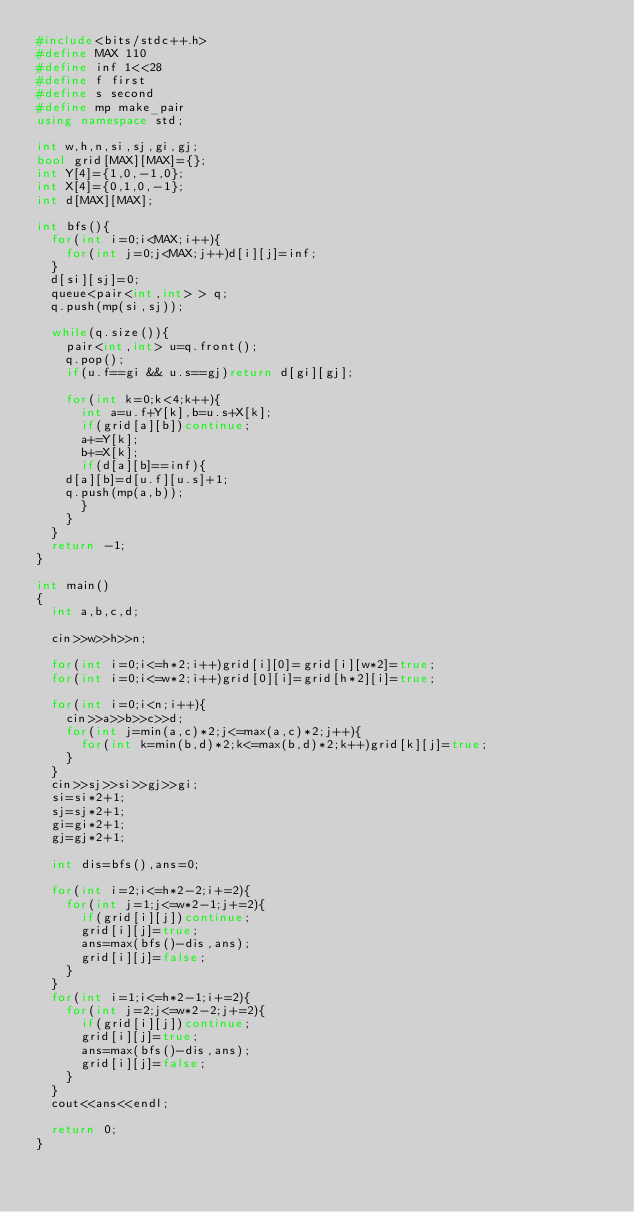<code> <loc_0><loc_0><loc_500><loc_500><_C++_>#include<bits/stdc++.h>
#define MAX 110
#define inf 1<<28
#define f first
#define s second
#define mp make_pair
using namespace std;

int w,h,n,si,sj,gi,gj;
bool grid[MAX][MAX]={};
int Y[4]={1,0,-1,0};
int X[4]={0,1,0,-1};
int d[MAX][MAX];

int bfs(){
  for(int i=0;i<MAX;i++){
    for(int j=0;j<MAX;j++)d[i][j]=inf;
  }
  d[si][sj]=0;
  queue<pair<int,int> > q;
  q.push(mp(si,sj));

  while(q.size()){
    pair<int,int> u=q.front();
    q.pop();
    if(u.f==gi && u.s==gj)return d[gi][gj];

    for(int k=0;k<4;k++){
      int a=u.f+Y[k],b=u.s+X[k];
      if(grid[a][b])continue;
      a+=Y[k];
      b+=X[k];
      if(d[a][b]==inf){
	d[a][b]=d[u.f][u.s]+1;
	q.push(mp(a,b));
      }
    }
  }
  return -1;
}

int main()
{
  int a,b,c,d;
 
  cin>>w>>h>>n;

  for(int i=0;i<=h*2;i++)grid[i][0]=grid[i][w*2]=true;
  for(int i=0;i<=w*2;i++)grid[0][i]=grid[h*2][i]=true;

  for(int i=0;i<n;i++){
    cin>>a>>b>>c>>d;
    for(int j=min(a,c)*2;j<=max(a,c)*2;j++){
      for(int k=min(b,d)*2;k<=max(b,d)*2;k++)grid[k][j]=true;
    }
  }
  cin>>sj>>si>>gj>>gi;
  si=si*2+1;
  sj=sj*2+1;
  gi=gi*2+1;
  gj=gj*2+1;

  int dis=bfs(),ans=0;

  for(int i=2;i<=h*2-2;i+=2){
    for(int j=1;j<=w*2-1;j+=2){
      if(grid[i][j])continue;
      grid[i][j]=true;
      ans=max(bfs()-dis,ans);
      grid[i][j]=false;
    }
  }
  for(int i=1;i<=h*2-1;i+=2){
    for(int j=2;j<=w*2-2;j+=2){
      if(grid[i][j])continue;
      grid[i][j]=true;
      ans=max(bfs()-dis,ans);
      grid[i][j]=false;
    }
  }
  cout<<ans<<endl;  

  return 0;
}</code> 